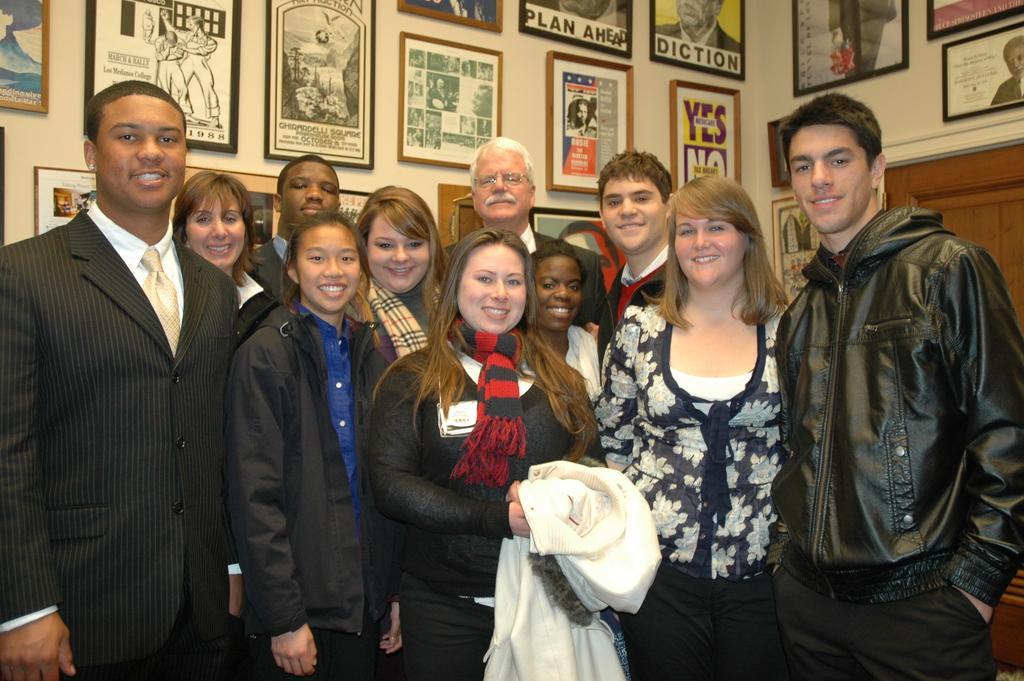How would you summarize this image in a sentence or two? In the picture we can see a group of men and women are standing on the floor and one woman is holding a cloth which is white in color and they all are smiling, in the background we can see a wall with photo frames and images on it. 